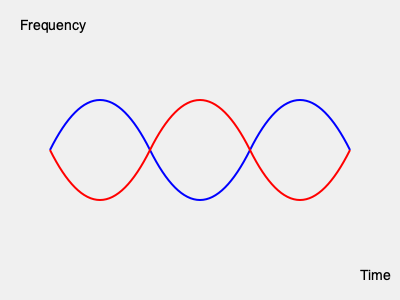In this 3D soundwave visualization, what audio characteristic is represented by the difference in amplitude between the blue and red waves? To interpret this 3D soundwave visualization:

1. Recognize that the horizontal axis represents time, and the vertical axis represents frequency.

2. Observe that there are two waveforms: one blue (top) and one red (bottom).

3. Notice that the blue and red waves have different amplitudes (heights) but similar overall shapes.

4. In audio terms, amplitude corresponds to volume or loudness.

5. The difference in amplitude between the two waves represents the stereo width or spatial positioning of the sound.

6. A larger difference between the blue and red waves indicates a wider stereo image or more distinct left-right channel separation.

7. This visualization technique is often used in audio production to analyze and adjust the stereo field of a recording.

Therefore, the difference in amplitude between the blue and red waves represents the stereo width or spatial positioning of the sound in the audio signal.
Answer: Stereo width 